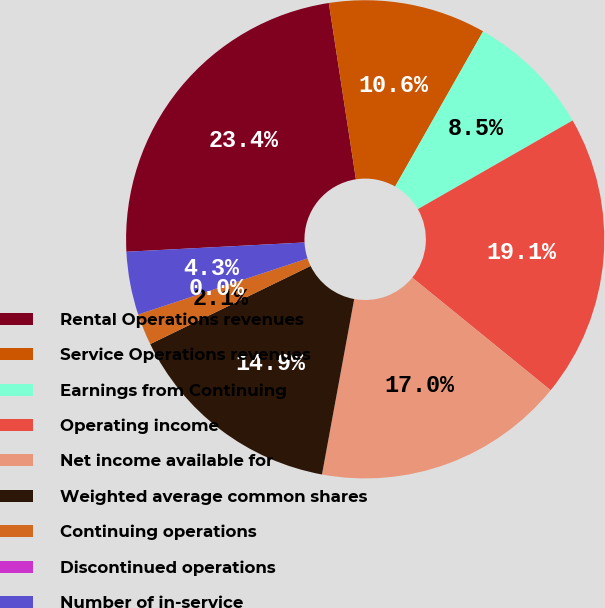Convert chart. <chart><loc_0><loc_0><loc_500><loc_500><pie_chart><fcel>Rental Operations revenues<fcel>Service Operations revenues<fcel>Earnings from Continuing<fcel>Operating income<fcel>Net income available for<fcel>Weighted average common shares<fcel>Continuing operations<fcel>Discontinued operations<fcel>Number of in-service<nl><fcel>23.4%<fcel>10.64%<fcel>8.51%<fcel>19.15%<fcel>17.02%<fcel>14.89%<fcel>2.13%<fcel>0.0%<fcel>4.26%<nl></chart> 